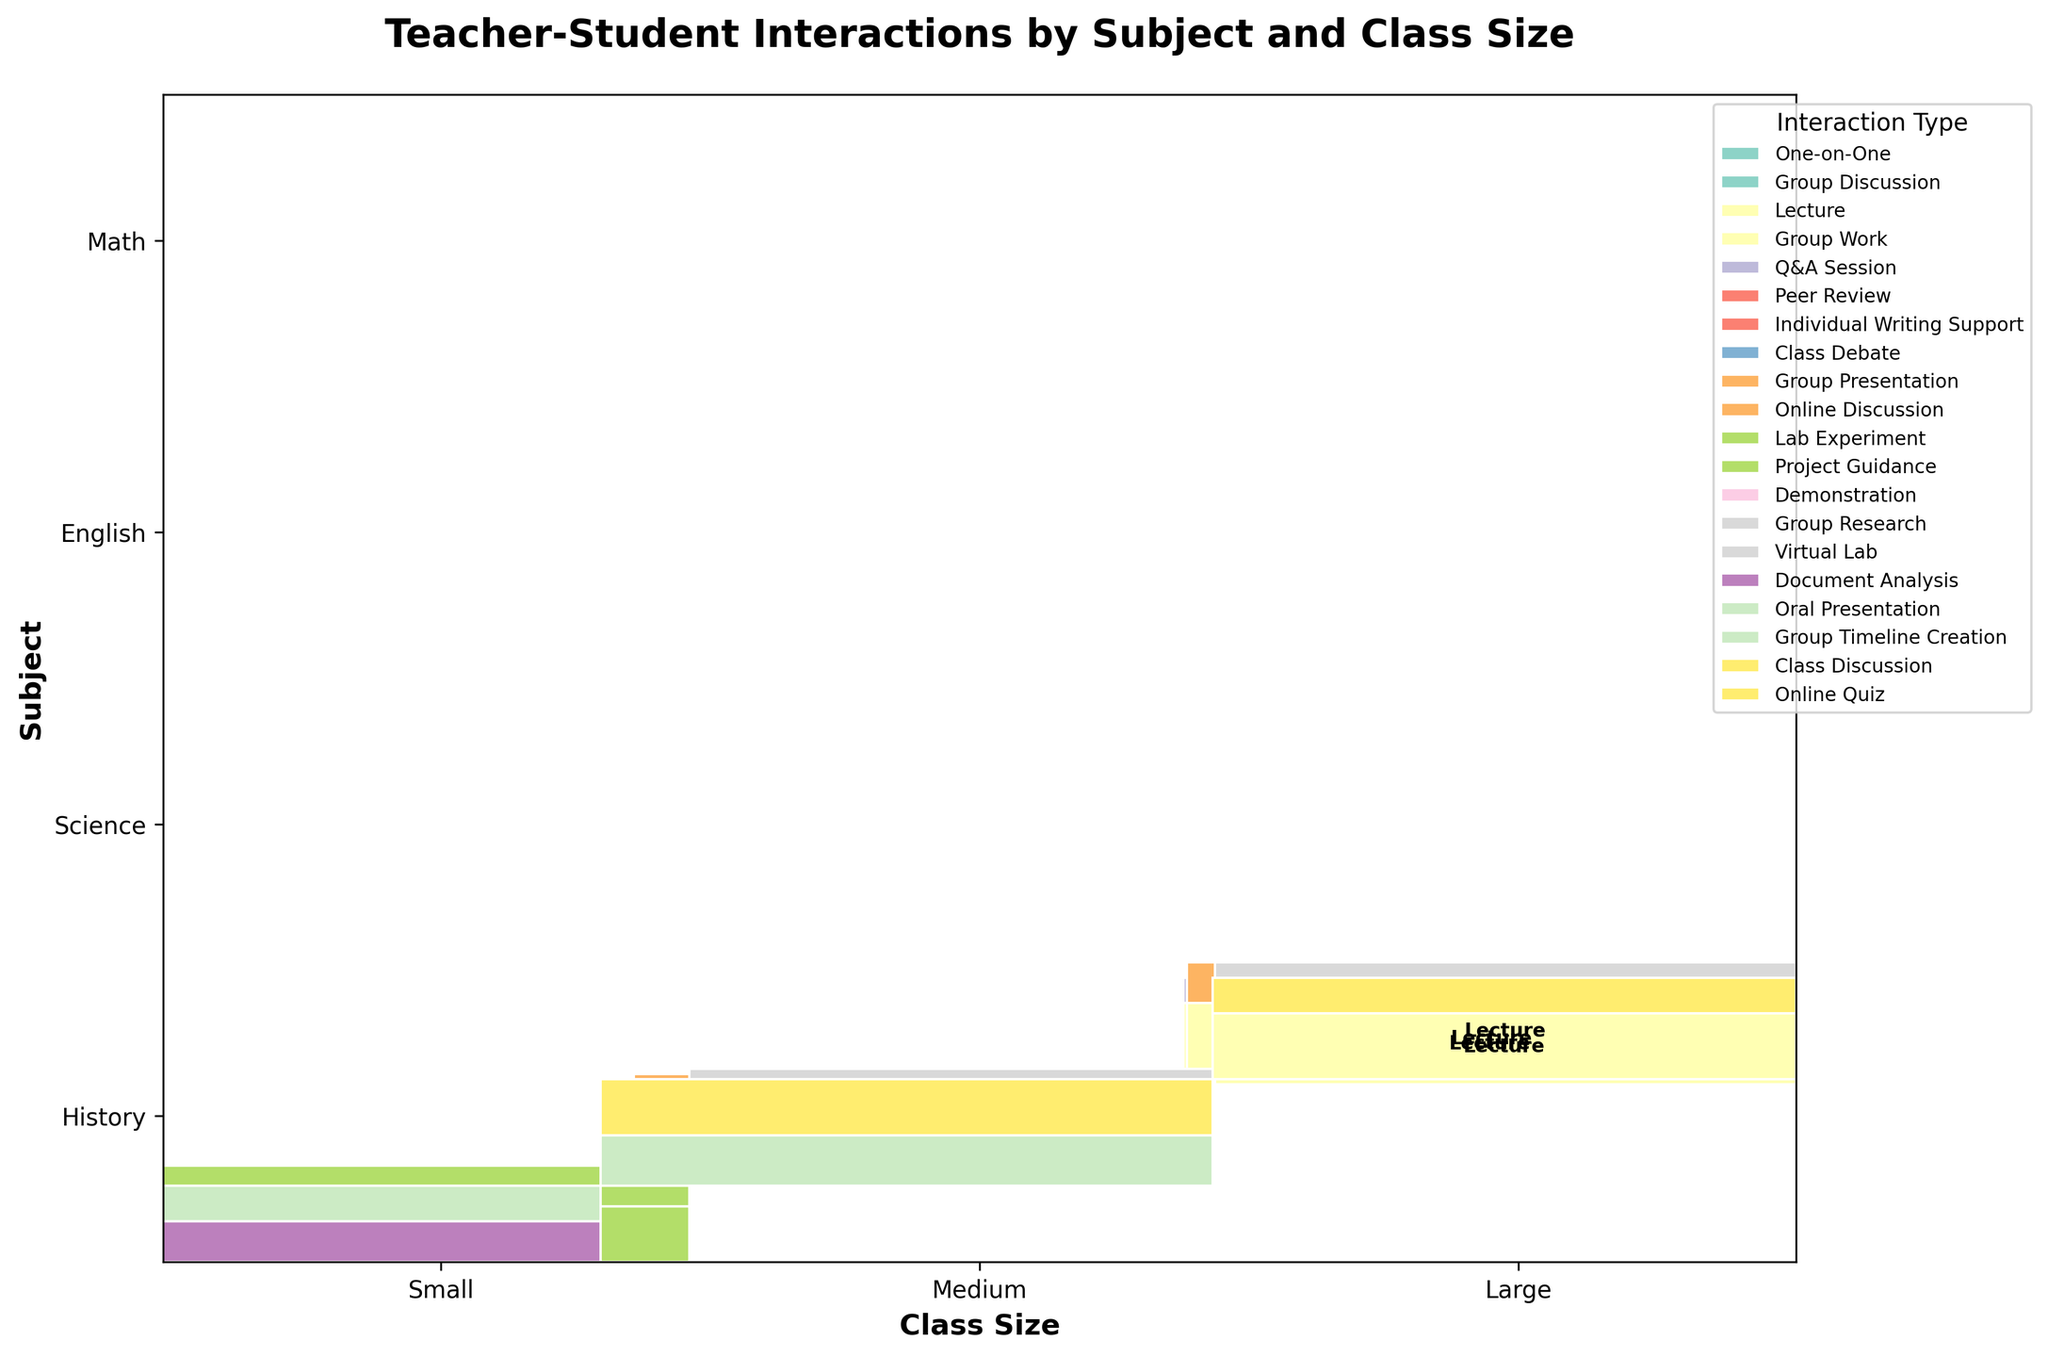What are the class sizes labeled on the x-axis? The x-axis labels represent the class sizes and appear in three categories. They are situated at specific tick positions.
Answer: Small, Medium, Large What subjects are shown on the y-axis? The y-axis labels represent subjects, and each subject name is placed at specific tick positions along the y-axis.
Answer: Math, English, Science, History Which interaction type is used most frequently in small classes for English? By looking at the segments under the 'Small' category for English, each interaction type's size can be compared visually.
Answer: Individual Writing Support What interaction types are associated with large history classes? By identifying the segments labeled under 'Large' for History, you can determine the predominant interaction types.
Answer: Lecture, Online Quiz In medium-sized math classes, which interaction type is more common: Lecture or Group Work? Compare the sizes of the segments labeled as 'Lecture' and 'Group Work' under the 'Medium' category for Math. Lecture occupies a larger area.
Answer: Lecture What is the sum of the frequencies for peer review and individual writing support in small English classes? Add the frequency counts for Peer Review and Individual Writing Support from the data. Peer Review has 35, and Individual Writing Support has 50, so 35 + 50 = 85.
Answer: 85 Which interaction type shows up in every subject and class size? By examining each subject and class size's segments, you observe that Lecture appears consistently across all categories.
Answer: Lecture Are Science interactions in small classes generally one type, and if so, which? Reviewing the segments for small Science classes shown greater uniformity suggests predominantly one interaction type.
Answer: Lab Experiment Compare the frequency of Q&A sessions in large Math classes to online quizzes in large History classes. Which is greater? Examining the relative size of segments under 'Q&A Session' for Math and 'Online Quiz' for History in the 'Large' category, Q&A sessions are smaller. The data confirms Q&A Sessions are 25 and Online Quizzes are 35.
Answer: Online Quiz What is the combined frequency of Group Discussion and Oral Presentation in small classes for Math and History respectively? Add up the frequency of Group Discussion in small Math classes and Oral Presentation in small History classes. Group Discussion is 30, and Oral Presentation is 35, so 30 + 35 = 65.
Answer: 65 